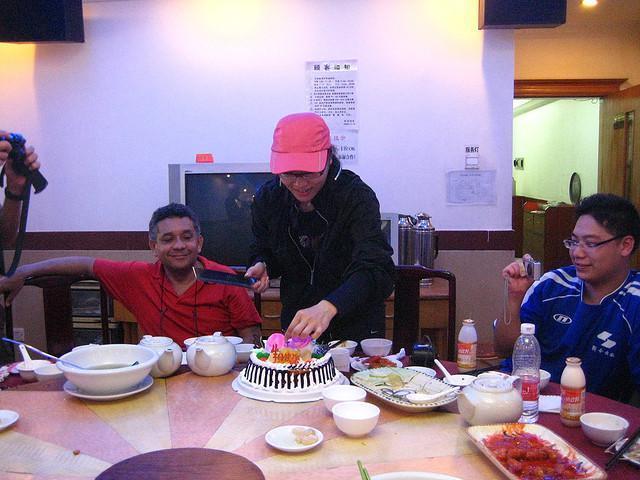How many cakes are on the table?
Give a very brief answer. 1. How many chairs are there?
Give a very brief answer. 2. How many people are there?
Give a very brief answer. 3. 